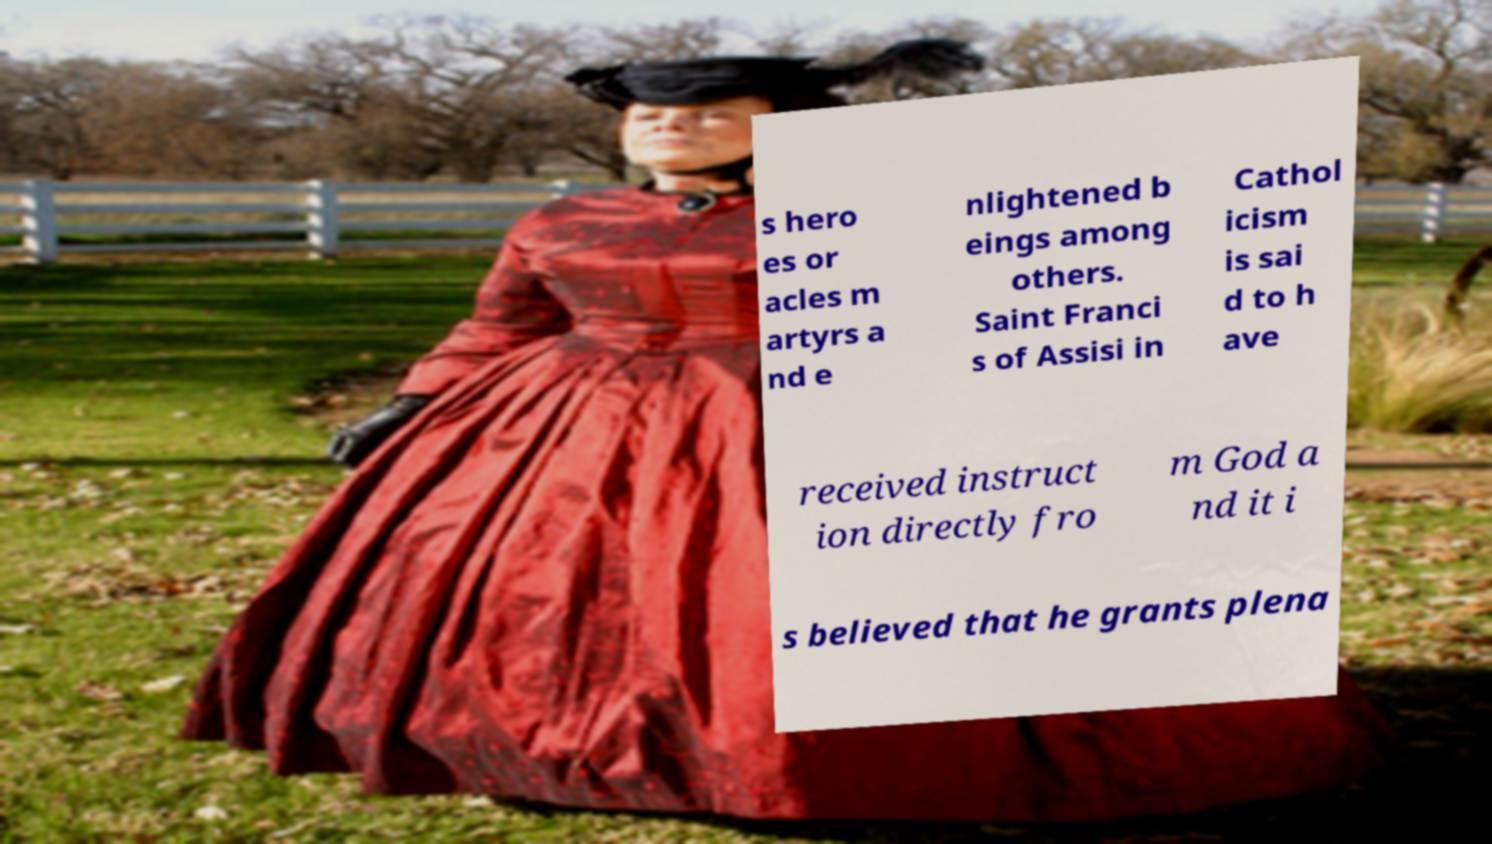Please read and relay the text visible in this image. What does it say? s hero es or acles m artyrs a nd e nlightened b eings among others. Saint Franci s of Assisi in Cathol icism is sai d to h ave received instruct ion directly fro m God a nd it i s believed that he grants plena 